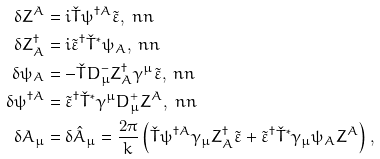<formula> <loc_0><loc_0><loc_500><loc_500>\delta Z ^ { A } & = i \check { T } \psi ^ { \dagger A } \tilde { \varepsilon } , \ n n \\ \delta Z ^ { \dagger } _ { A } & = i \tilde { \varepsilon } ^ { \dagger } \check { T } ^ { * } \psi _ { A } , \ n n \\ \delta \psi _ { A } & = - \check { T } D ^ { - } _ { \mu } Z ^ { \dagger } _ { A } \gamma ^ { \mu } \tilde { \varepsilon } , \ n n \\ \delta \psi ^ { \dagger A } & = \tilde { \varepsilon } ^ { \dagger } \check { T } ^ { * } \gamma ^ { \mu } D ^ { + } _ { \mu } Z ^ { A } , \ n n \\ \delta A _ { \mu } & = \delta \hat { A } _ { \mu } = \frac { 2 \pi } { k } \left ( \check { T } \psi ^ { \dagger A } \gamma _ { \mu } Z ^ { \dagger } _ { A } \tilde { \varepsilon } + \tilde { \varepsilon } ^ { \dagger } \check { T } ^ { * } \gamma _ { \mu } \psi _ { A } Z ^ { A } \right ) ,</formula> 